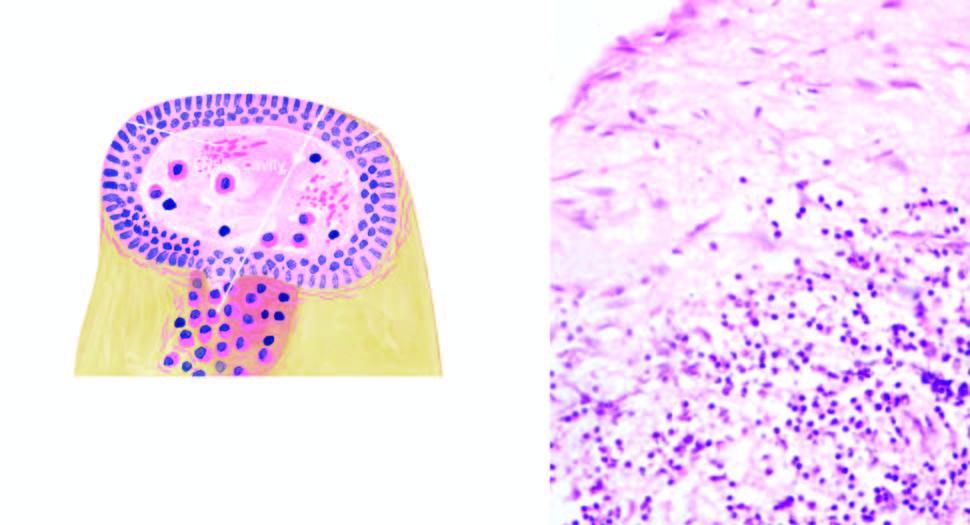s the cyst wall densely infiltrated by chronic inflammatory cells, chiefly lymphocytes, plasma cells and macrophages?
Answer the question using a single word or phrase. Yes 